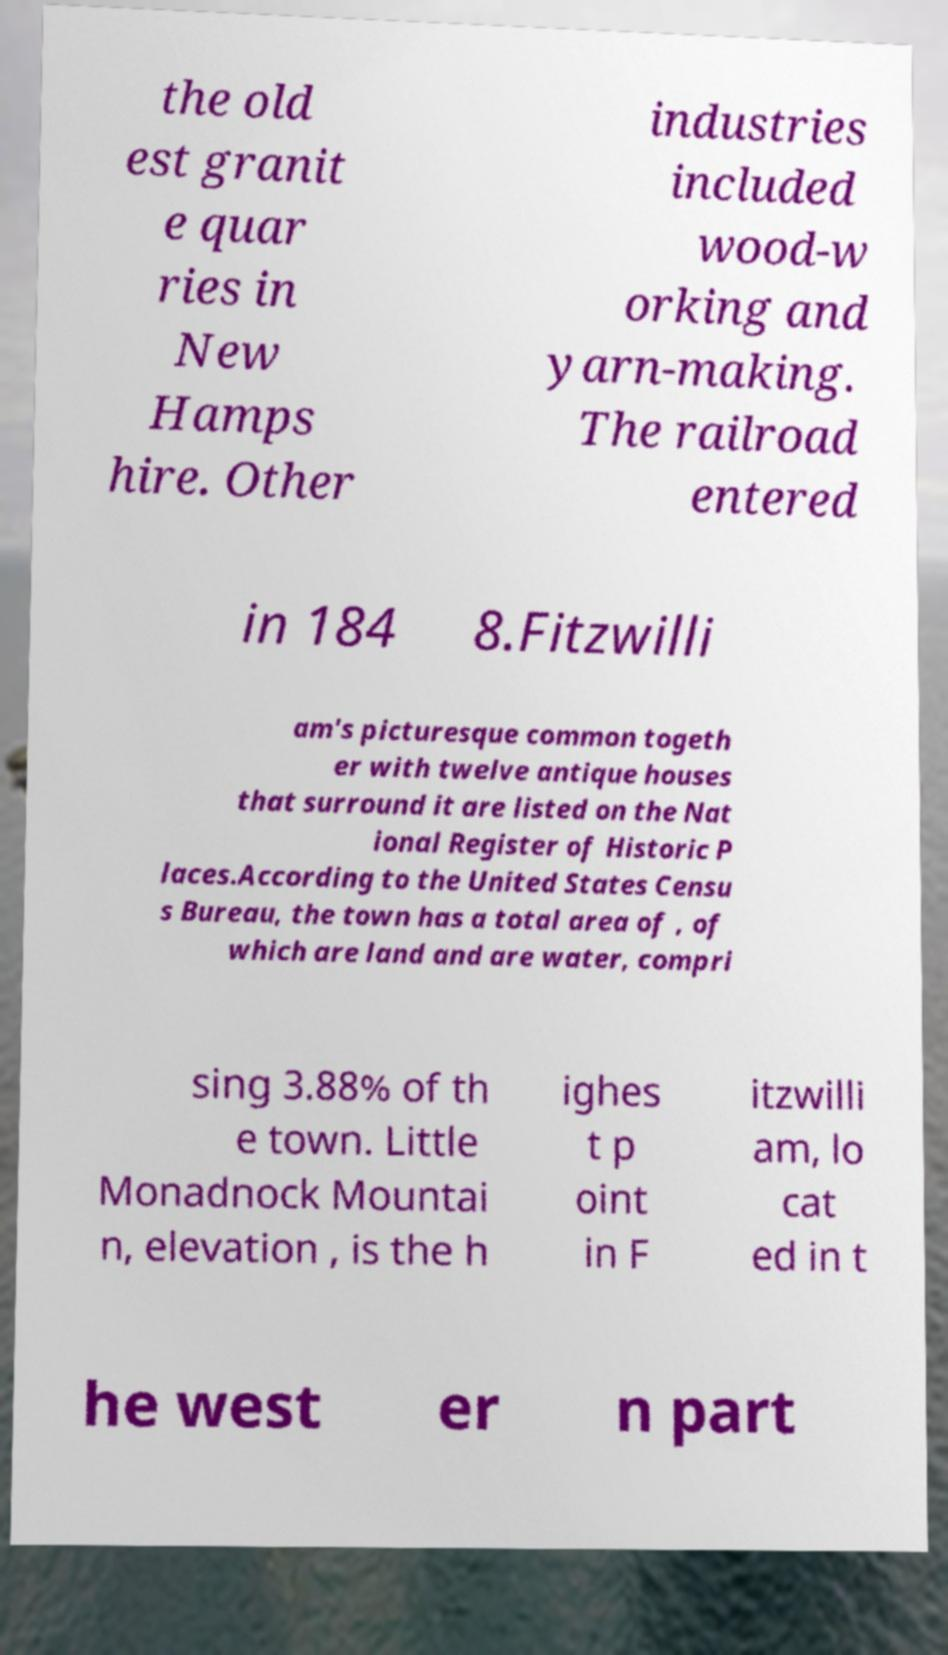I need the written content from this picture converted into text. Can you do that? the old est granit e quar ries in New Hamps hire. Other industries included wood-w orking and yarn-making. The railroad entered in 184 8.Fitzwilli am's picturesque common togeth er with twelve antique houses that surround it are listed on the Nat ional Register of Historic P laces.According to the United States Censu s Bureau, the town has a total area of , of which are land and are water, compri sing 3.88% of th e town. Little Monadnock Mountai n, elevation , is the h ighes t p oint in F itzwilli am, lo cat ed in t he west er n part 